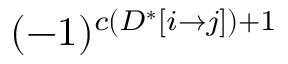Convert formula to latex. <formula><loc_0><loc_0><loc_500><loc_500>( - 1 ) ^ { c ( D ^ { * } [ i \rightarrow j ] ) + 1 }</formula> 